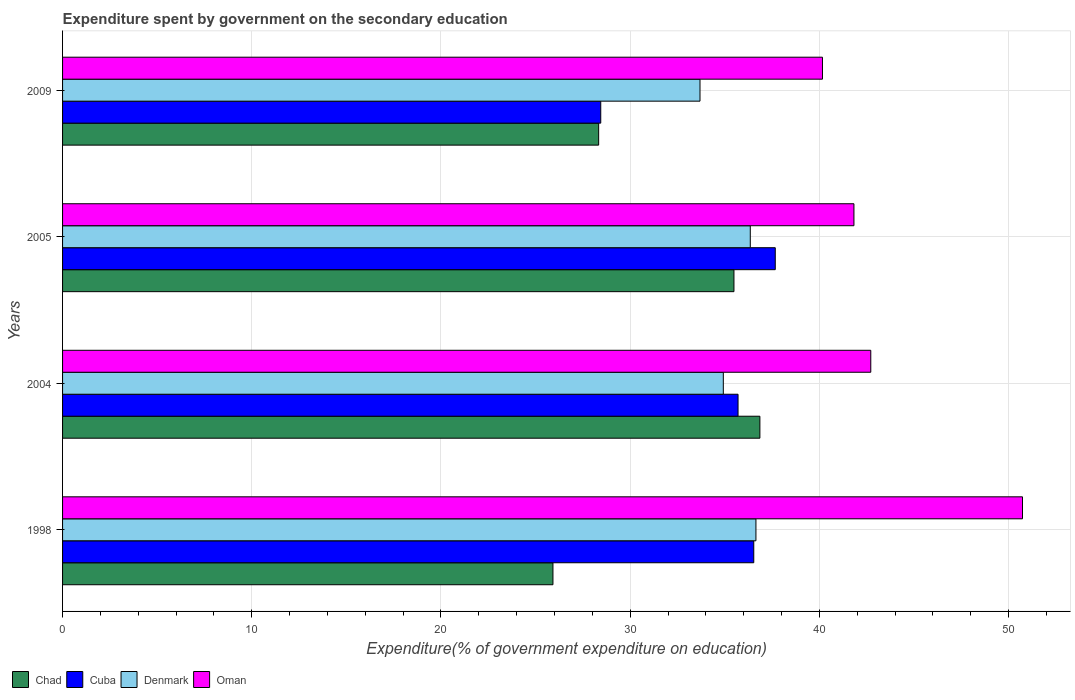How many bars are there on the 4th tick from the top?
Offer a terse response. 4. What is the expenditure spent by government on the secondary education in Cuba in 2009?
Provide a succinct answer. 28.44. Across all years, what is the maximum expenditure spent by government on the secondary education in Oman?
Ensure brevity in your answer.  50.73. Across all years, what is the minimum expenditure spent by government on the secondary education in Cuba?
Give a very brief answer. 28.44. In which year was the expenditure spent by government on the secondary education in Denmark maximum?
Give a very brief answer. 1998. In which year was the expenditure spent by government on the secondary education in Chad minimum?
Give a very brief answer. 1998. What is the total expenditure spent by government on the secondary education in Cuba in the graph?
Provide a short and direct response. 138.35. What is the difference between the expenditure spent by government on the secondary education in Denmark in 2004 and that in 2005?
Provide a succinct answer. -1.43. What is the difference between the expenditure spent by government on the secondary education in Denmark in 2005 and the expenditure spent by government on the secondary education in Chad in 2009?
Provide a succinct answer. 8.01. What is the average expenditure spent by government on the secondary education in Cuba per year?
Provide a short and direct response. 34.59. In the year 2005, what is the difference between the expenditure spent by government on the secondary education in Denmark and expenditure spent by government on the secondary education in Oman?
Make the answer very short. -5.48. In how many years, is the expenditure spent by government on the secondary education in Cuba greater than 38 %?
Offer a very short reply. 0. What is the ratio of the expenditure spent by government on the secondary education in Cuba in 2005 to that in 2009?
Ensure brevity in your answer.  1.32. Is the expenditure spent by government on the secondary education in Denmark in 2005 less than that in 2009?
Your answer should be compact. No. Is the difference between the expenditure spent by government on the secondary education in Denmark in 1998 and 2009 greater than the difference between the expenditure spent by government on the secondary education in Oman in 1998 and 2009?
Offer a very short reply. No. What is the difference between the highest and the second highest expenditure spent by government on the secondary education in Oman?
Your answer should be compact. 8.02. What is the difference between the highest and the lowest expenditure spent by government on the secondary education in Oman?
Your answer should be very brief. 10.57. Is the sum of the expenditure spent by government on the secondary education in Cuba in 2004 and 2009 greater than the maximum expenditure spent by government on the secondary education in Chad across all years?
Your answer should be compact. Yes. Is it the case that in every year, the sum of the expenditure spent by government on the secondary education in Denmark and expenditure spent by government on the secondary education in Oman is greater than the sum of expenditure spent by government on the secondary education in Cuba and expenditure spent by government on the secondary education in Chad?
Make the answer very short. No. What does the 1st bar from the top in 2004 represents?
Give a very brief answer. Oman. What does the 4th bar from the bottom in 2005 represents?
Provide a succinct answer. Oman. Is it the case that in every year, the sum of the expenditure spent by government on the secondary education in Denmark and expenditure spent by government on the secondary education in Oman is greater than the expenditure spent by government on the secondary education in Chad?
Ensure brevity in your answer.  Yes. Are the values on the major ticks of X-axis written in scientific E-notation?
Your answer should be very brief. No. Does the graph contain any zero values?
Provide a succinct answer. No. Where does the legend appear in the graph?
Ensure brevity in your answer.  Bottom left. How are the legend labels stacked?
Provide a short and direct response. Horizontal. What is the title of the graph?
Your answer should be compact. Expenditure spent by government on the secondary education. Does "Yemen, Rep." appear as one of the legend labels in the graph?
Offer a terse response. No. What is the label or title of the X-axis?
Your answer should be compact. Expenditure(% of government expenditure on education). What is the Expenditure(% of government expenditure on education) in Chad in 1998?
Your answer should be compact. 25.92. What is the Expenditure(% of government expenditure on education) of Cuba in 1998?
Your answer should be compact. 36.53. What is the Expenditure(% of government expenditure on education) in Denmark in 1998?
Your answer should be compact. 36.65. What is the Expenditure(% of government expenditure on education) in Oman in 1998?
Your answer should be compact. 50.73. What is the Expenditure(% of government expenditure on education) in Chad in 2004?
Your response must be concise. 36.86. What is the Expenditure(% of government expenditure on education) in Cuba in 2004?
Provide a succinct answer. 35.7. What is the Expenditure(% of government expenditure on education) of Denmark in 2004?
Offer a very short reply. 34.92. What is the Expenditure(% of government expenditure on education) of Oman in 2004?
Give a very brief answer. 42.72. What is the Expenditure(% of government expenditure on education) of Chad in 2005?
Your answer should be very brief. 35.48. What is the Expenditure(% of government expenditure on education) in Cuba in 2005?
Provide a succinct answer. 37.67. What is the Expenditure(% of government expenditure on education) of Denmark in 2005?
Ensure brevity in your answer.  36.35. What is the Expenditure(% of government expenditure on education) of Oman in 2005?
Offer a very short reply. 41.83. What is the Expenditure(% of government expenditure on education) in Chad in 2009?
Provide a short and direct response. 28.33. What is the Expenditure(% of government expenditure on education) in Cuba in 2009?
Provide a short and direct response. 28.44. What is the Expenditure(% of government expenditure on education) in Denmark in 2009?
Your answer should be compact. 33.69. What is the Expenditure(% of government expenditure on education) in Oman in 2009?
Your answer should be very brief. 40.16. Across all years, what is the maximum Expenditure(% of government expenditure on education) in Chad?
Keep it short and to the point. 36.86. Across all years, what is the maximum Expenditure(% of government expenditure on education) in Cuba?
Your response must be concise. 37.67. Across all years, what is the maximum Expenditure(% of government expenditure on education) in Denmark?
Your response must be concise. 36.65. Across all years, what is the maximum Expenditure(% of government expenditure on education) in Oman?
Provide a succinct answer. 50.73. Across all years, what is the minimum Expenditure(% of government expenditure on education) in Chad?
Ensure brevity in your answer.  25.92. Across all years, what is the minimum Expenditure(% of government expenditure on education) in Cuba?
Provide a short and direct response. 28.44. Across all years, what is the minimum Expenditure(% of government expenditure on education) of Denmark?
Ensure brevity in your answer.  33.69. Across all years, what is the minimum Expenditure(% of government expenditure on education) in Oman?
Provide a short and direct response. 40.16. What is the total Expenditure(% of government expenditure on education) in Chad in the graph?
Your answer should be compact. 126.59. What is the total Expenditure(% of government expenditure on education) in Cuba in the graph?
Offer a very short reply. 138.35. What is the total Expenditure(% of government expenditure on education) in Denmark in the graph?
Provide a short and direct response. 141.61. What is the total Expenditure(% of government expenditure on education) in Oman in the graph?
Provide a short and direct response. 175.44. What is the difference between the Expenditure(% of government expenditure on education) of Chad in 1998 and that in 2004?
Offer a terse response. -10.94. What is the difference between the Expenditure(% of government expenditure on education) in Cuba in 1998 and that in 2004?
Give a very brief answer. 0.83. What is the difference between the Expenditure(% of government expenditure on education) in Denmark in 1998 and that in 2004?
Ensure brevity in your answer.  1.72. What is the difference between the Expenditure(% of government expenditure on education) in Oman in 1998 and that in 2004?
Offer a terse response. 8.02. What is the difference between the Expenditure(% of government expenditure on education) of Chad in 1998 and that in 2005?
Give a very brief answer. -9.57. What is the difference between the Expenditure(% of government expenditure on education) of Cuba in 1998 and that in 2005?
Keep it short and to the point. -1.14. What is the difference between the Expenditure(% of government expenditure on education) of Denmark in 1998 and that in 2005?
Provide a succinct answer. 0.3. What is the difference between the Expenditure(% of government expenditure on education) of Oman in 1998 and that in 2005?
Offer a very short reply. 8.91. What is the difference between the Expenditure(% of government expenditure on education) of Chad in 1998 and that in 2009?
Offer a very short reply. -2.42. What is the difference between the Expenditure(% of government expenditure on education) in Cuba in 1998 and that in 2009?
Ensure brevity in your answer.  8.09. What is the difference between the Expenditure(% of government expenditure on education) in Denmark in 1998 and that in 2009?
Offer a very short reply. 2.96. What is the difference between the Expenditure(% of government expenditure on education) in Oman in 1998 and that in 2009?
Provide a short and direct response. 10.57. What is the difference between the Expenditure(% of government expenditure on education) of Chad in 2004 and that in 2005?
Give a very brief answer. 1.37. What is the difference between the Expenditure(% of government expenditure on education) of Cuba in 2004 and that in 2005?
Offer a terse response. -1.97. What is the difference between the Expenditure(% of government expenditure on education) of Denmark in 2004 and that in 2005?
Keep it short and to the point. -1.43. What is the difference between the Expenditure(% of government expenditure on education) of Oman in 2004 and that in 2005?
Provide a short and direct response. 0.89. What is the difference between the Expenditure(% of government expenditure on education) in Chad in 2004 and that in 2009?
Your answer should be compact. 8.52. What is the difference between the Expenditure(% of government expenditure on education) of Cuba in 2004 and that in 2009?
Keep it short and to the point. 7.26. What is the difference between the Expenditure(% of government expenditure on education) of Denmark in 2004 and that in 2009?
Your response must be concise. 1.23. What is the difference between the Expenditure(% of government expenditure on education) in Oman in 2004 and that in 2009?
Give a very brief answer. 2.55. What is the difference between the Expenditure(% of government expenditure on education) in Chad in 2005 and that in 2009?
Offer a terse response. 7.15. What is the difference between the Expenditure(% of government expenditure on education) in Cuba in 2005 and that in 2009?
Offer a terse response. 9.22. What is the difference between the Expenditure(% of government expenditure on education) of Denmark in 2005 and that in 2009?
Your answer should be very brief. 2.66. What is the difference between the Expenditure(% of government expenditure on education) in Oman in 2005 and that in 2009?
Make the answer very short. 1.66. What is the difference between the Expenditure(% of government expenditure on education) in Chad in 1998 and the Expenditure(% of government expenditure on education) in Cuba in 2004?
Provide a short and direct response. -9.78. What is the difference between the Expenditure(% of government expenditure on education) in Chad in 1998 and the Expenditure(% of government expenditure on education) in Denmark in 2004?
Keep it short and to the point. -9. What is the difference between the Expenditure(% of government expenditure on education) of Chad in 1998 and the Expenditure(% of government expenditure on education) of Oman in 2004?
Offer a terse response. -16.8. What is the difference between the Expenditure(% of government expenditure on education) of Cuba in 1998 and the Expenditure(% of government expenditure on education) of Denmark in 2004?
Your answer should be very brief. 1.61. What is the difference between the Expenditure(% of government expenditure on education) of Cuba in 1998 and the Expenditure(% of government expenditure on education) of Oman in 2004?
Offer a terse response. -6.18. What is the difference between the Expenditure(% of government expenditure on education) in Denmark in 1998 and the Expenditure(% of government expenditure on education) in Oman in 2004?
Provide a succinct answer. -6.07. What is the difference between the Expenditure(% of government expenditure on education) in Chad in 1998 and the Expenditure(% of government expenditure on education) in Cuba in 2005?
Provide a succinct answer. -11.75. What is the difference between the Expenditure(% of government expenditure on education) of Chad in 1998 and the Expenditure(% of government expenditure on education) of Denmark in 2005?
Provide a short and direct response. -10.43. What is the difference between the Expenditure(% of government expenditure on education) in Chad in 1998 and the Expenditure(% of government expenditure on education) in Oman in 2005?
Give a very brief answer. -15.91. What is the difference between the Expenditure(% of government expenditure on education) of Cuba in 1998 and the Expenditure(% of government expenditure on education) of Denmark in 2005?
Your response must be concise. 0.18. What is the difference between the Expenditure(% of government expenditure on education) in Cuba in 1998 and the Expenditure(% of government expenditure on education) in Oman in 2005?
Provide a succinct answer. -5.29. What is the difference between the Expenditure(% of government expenditure on education) in Denmark in 1998 and the Expenditure(% of government expenditure on education) in Oman in 2005?
Ensure brevity in your answer.  -5.18. What is the difference between the Expenditure(% of government expenditure on education) in Chad in 1998 and the Expenditure(% of government expenditure on education) in Cuba in 2009?
Keep it short and to the point. -2.53. What is the difference between the Expenditure(% of government expenditure on education) of Chad in 1998 and the Expenditure(% of government expenditure on education) of Denmark in 2009?
Offer a very short reply. -7.77. What is the difference between the Expenditure(% of government expenditure on education) of Chad in 1998 and the Expenditure(% of government expenditure on education) of Oman in 2009?
Offer a very short reply. -14.24. What is the difference between the Expenditure(% of government expenditure on education) in Cuba in 1998 and the Expenditure(% of government expenditure on education) in Denmark in 2009?
Your response must be concise. 2.84. What is the difference between the Expenditure(% of government expenditure on education) in Cuba in 1998 and the Expenditure(% of government expenditure on education) in Oman in 2009?
Provide a short and direct response. -3.63. What is the difference between the Expenditure(% of government expenditure on education) in Denmark in 1998 and the Expenditure(% of government expenditure on education) in Oman in 2009?
Make the answer very short. -3.52. What is the difference between the Expenditure(% of government expenditure on education) of Chad in 2004 and the Expenditure(% of government expenditure on education) of Cuba in 2005?
Give a very brief answer. -0.81. What is the difference between the Expenditure(% of government expenditure on education) of Chad in 2004 and the Expenditure(% of government expenditure on education) of Denmark in 2005?
Make the answer very short. 0.51. What is the difference between the Expenditure(% of government expenditure on education) in Chad in 2004 and the Expenditure(% of government expenditure on education) in Oman in 2005?
Offer a terse response. -4.97. What is the difference between the Expenditure(% of government expenditure on education) in Cuba in 2004 and the Expenditure(% of government expenditure on education) in Denmark in 2005?
Offer a very short reply. -0.65. What is the difference between the Expenditure(% of government expenditure on education) in Cuba in 2004 and the Expenditure(% of government expenditure on education) in Oman in 2005?
Make the answer very short. -6.13. What is the difference between the Expenditure(% of government expenditure on education) of Denmark in 2004 and the Expenditure(% of government expenditure on education) of Oman in 2005?
Provide a short and direct response. -6.9. What is the difference between the Expenditure(% of government expenditure on education) in Chad in 2004 and the Expenditure(% of government expenditure on education) in Cuba in 2009?
Offer a very short reply. 8.41. What is the difference between the Expenditure(% of government expenditure on education) of Chad in 2004 and the Expenditure(% of government expenditure on education) of Denmark in 2009?
Your answer should be compact. 3.17. What is the difference between the Expenditure(% of government expenditure on education) in Chad in 2004 and the Expenditure(% of government expenditure on education) in Oman in 2009?
Your answer should be very brief. -3.31. What is the difference between the Expenditure(% of government expenditure on education) of Cuba in 2004 and the Expenditure(% of government expenditure on education) of Denmark in 2009?
Make the answer very short. 2.01. What is the difference between the Expenditure(% of government expenditure on education) of Cuba in 2004 and the Expenditure(% of government expenditure on education) of Oman in 2009?
Make the answer very short. -4.46. What is the difference between the Expenditure(% of government expenditure on education) in Denmark in 2004 and the Expenditure(% of government expenditure on education) in Oman in 2009?
Give a very brief answer. -5.24. What is the difference between the Expenditure(% of government expenditure on education) in Chad in 2005 and the Expenditure(% of government expenditure on education) in Cuba in 2009?
Make the answer very short. 7.04. What is the difference between the Expenditure(% of government expenditure on education) in Chad in 2005 and the Expenditure(% of government expenditure on education) in Denmark in 2009?
Your answer should be very brief. 1.79. What is the difference between the Expenditure(% of government expenditure on education) of Chad in 2005 and the Expenditure(% of government expenditure on education) of Oman in 2009?
Your answer should be very brief. -4.68. What is the difference between the Expenditure(% of government expenditure on education) of Cuba in 2005 and the Expenditure(% of government expenditure on education) of Denmark in 2009?
Provide a short and direct response. 3.98. What is the difference between the Expenditure(% of government expenditure on education) in Cuba in 2005 and the Expenditure(% of government expenditure on education) in Oman in 2009?
Ensure brevity in your answer.  -2.49. What is the difference between the Expenditure(% of government expenditure on education) of Denmark in 2005 and the Expenditure(% of government expenditure on education) of Oman in 2009?
Your answer should be very brief. -3.82. What is the average Expenditure(% of government expenditure on education) of Chad per year?
Your answer should be very brief. 31.65. What is the average Expenditure(% of government expenditure on education) in Cuba per year?
Keep it short and to the point. 34.59. What is the average Expenditure(% of government expenditure on education) of Denmark per year?
Your response must be concise. 35.4. What is the average Expenditure(% of government expenditure on education) of Oman per year?
Provide a succinct answer. 43.86. In the year 1998, what is the difference between the Expenditure(% of government expenditure on education) of Chad and Expenditure(% of government expenditure on education) of Cuba?
Offer a terse response. -10.61. In the year 1998, what is the difference between the Expenditure(% of government expenditure on education) in Chad and Expenditure(% of government expenditure on education) in Denmark?
Keep it short and to the point. -10.73. In the year 1998, what is the difference between the Expenditure(% of government expenditure on education) in Chad and Expenditure(% of government expenditure on education) in Oman?
Your response must be concise. -24.82. In the year 1998, what is the difference between the Expenditure(% of government expenditure on education) of Cuba and Expenditure(% of government expenditure on education) of Denmark?
Keep it short and to the point. -0.12. In the year 1998, what is the difference between the Expenditure(% of government expenditure on education) of Cuba and Expenditure(% of government expenditure on education) of Oman?
Your response must be concise. -14.2. In the year 1998, what is the difference between the Expenditure(% of government expenditure on education) in Denmark and Expenditure(% of government expenditure on education) in Oman?
Offer a terse response. -14.09. In the year 2004, what is the difference between the Expenditure(% of government expenditure on education) in Chad and Expenditure(% of government expenditure on education) in Cuba?
Offer a terse response. 1.15. In the year 2004, what is the difference between the Expenditure(% of government expenditure on education) in Chad and Expenditure(% of government expenditure on education) in Denmark?
Your answer should be very brief. 1.93. In the year 2004, what is the difference between the Expenditure(% of government expenditure on education) in Chad and Expenditure(% of government expenditure on education) in Oman?
Keep it short and to the point. -5.86. In the year 2004, what is the difference between the Expenditure(% of government expenditure on education) of Cuba and Expenditure(% of government expenditure on education) of Denmark?
Ensure brevity in your answer.  0.78. In the year 2004, what is the difference between the Expenditure(% of government expenditure on education) of Cuba and Expenditure(% of government expenditure on education) of Oman?
Offer a terse response. -7.02. In the year 2004, what is the difference between the Expenditure(% of government expenditure on education) in Denmark and Expenditure(% of government expenditure on education) in Oman?
Ensure brevity in your answer.  -7.79. In the year 2005, what is the difference between the Expenditure(% of government expenditure on education) in Chad and Expenditure(% of government expenditure on education) in Cuba?
Offer a terse response. -2.18. In the year 2005, what is the difference between the Expenditure(% of government expenditure on education) in Chad and Expenditure(% of government expenditure on education) in Denmark?
Ensure brevity in your answer.  -0.86. In the year 2005, what is the difference between the Expenditure(% of government expenditure on education) in Chad and Expenditure(% of government expenditure on education) in Oman?
Give a very brief answer. -6.34. In the year 2005, what is the difference between the Expenditure(% of government expenditure on education) of Cuba and Expenditure(% of government expenditure on education) of Denmark?
Offer a terse response. 1.32. In the year 2005, what is the difference between the Expenditure(% of government expenditure on education) of Cuba and Expenditure(% of government expenditure on education) of Oman?
Your answer should be very brief. -4.16. In the year 2005, what is the difference between the Expenditure(% of government expenditure on education) of Denmark and Expenditure(% of government expenditure on education) of Oman?
Keep it short and to the point. -5.48. In the year 2009, what is the difference between the Expenditure(% of government expenditure on education) of Chad and Expenditure(% of government expenditure on education) of Cuba?
Keep it short and to the point. -0.11. In the year 2009, what is the difference between the Expenditure(% of government expenditure on education) in Chad and Expenditure(% of government expenditure on education) in Denmark?
Offer a terse response. -5.36. In the year 2009, what is the difference between the Expenditure(% of government expenditure on education) in Chad and Expenditure(% of government expenditure on education) in Oman?
Provide a succinct answer. -11.83. In the year 2009, what is the difference between the Expenditure(% of government expenditure on education) in Cuba and Expenditure(% of government expenditure on education) in Denmark?
Make the answer very short. -5.25. In the year 2009, what is the difference between the Expenditure(% of government expenditure on education) of Cuba and Expenditure(% of government expenditure on education) of Oman?
Ensure brevity in your answer.  -11.72. In the year 2009, what is the difference between the Expenditure(% of government expenditure on education) of Denmark and Expenditure(% of government expenditure on education) of Oman?
Keep it short and to the point. -6.47. What is the ratio of the Expenditure(% of government expenditure on education) of Chad in 1998 to that in 2004?
Provide a succinct answer. 0.7. What is the ratio of the Expenditure(% of government expenditure on education) in Cuba in 1998 to that in 2004?
Keep it short and to the point. 1.02. What is the ratio of the Expenditure(% of government expenditure on education) of Denmark in 1998 to that in 2004?
Your answer should be very brief. 1.05. What is the ratio of the Expenditure(% of government expenditure on education) of Oman in 1998 to that in 2004?
Give a very brief answer. 1.19. What is the ratio of the Expenditure(% of government expenditure on education) in Chad in 1998 to that in 2005?
Keep it short and to the point. 0.73. What is the ratio of the Expenditure(% of government expenditure on education) in Cuba in 1998 to that in 2005?
Ensure brevity in your answer.  0.97. What is the ratio of the Expenditure(% of government expenditure on education) of Denmark in 1998 to that in 2005?
Provide a succinct answer. 1.01. What is the ratio of the Expenditure(% of government expenditure on education) of Oman in 1998 to that in 2005?
Keep it short and to the point. 1.21. What is the ratio of the Expenditure(% of government expenditure on education) in Chad in 1998 to that in 2009?
Offer a terse response. 0.91. What is the ratio of the Expenditure(% of government expenditure on education) in Cuba in 1998 to that in 2009?
Your response must be concise. 1.28. What is the ratio of the Expenditure(% of government expenditure on education) of Denmark in 1998 to that in 2009?
Your response must be concise. 1.09. What is the ratio of the Expenditure(% of government expenditure on education) of Oman in 1998 to that in 2009?
Offer a terse response. 1.26. What is the ratio of the Expenditure(% of government expenditure on education) in Chad in 2004 to that in 2005?
Keep it short and to the point. 1.04. What is the ratio of the Expenditure(% of government expenditure on education) of Cuba in 2004 to that in 2005?
Ensure brevity in your answer.  0.95. What is the ratio of the Expenditure(% of government expenditure on education) of Denmark in 2004 to that in 2005?
Give a very brief answer. 0.96. What is the ratio of the Expenditure(% of government expenditure on education) of Oman in 2004 to that in 2005?
Make the answer very short. 1.02. What is the ratio of the Expenditure(% of government expenditure on education) of Chad in 2004 to that in 2009?
Provide a succinct answer. 1.3. What is the ratio of the Expenditure(% of government expenditure on education) in Cuba in 2004 to that in 2009?
Offer a terse response. 1.26. What is the ratio of the Expenditure(% of government expenditure on education) of Denmark in 2004 to that in 2009?
Provide a succinct answer. 1.04. What is the ratio of the Expenditure(% of government expenditure on education) of Oman in 2004 to that in 2009?
Your response must be concise. 1.06. What is the ratio of the Expenditure(% of government expenditure on education) of Chad in 2005 to that in 2009?
Your answer should be very brief. 1.25. What is the ratio of the Expenditure(% of government expenditure on education) in Cuba in 2005 to that in 2009?
Your answer should be very brief. 1.32. What is the ratio of the Expenditure(% of government expenditure on education) of Denmark in 2005 to that in 2009?
Keep it short and to the point. 1.08. What is the ratio of the Expenditure(% of government expenditure on education) of Oman in 2005 to that in 2009?
Make the answer very short. 1.04. What is the difference between the highest and the second highest Expenditure(% of government expenditure on education) in Chad?
Keep it short and to the point. 1.37. What is the difference between the highest and the second highest Expenditure(% of government expenditure on education) of Cuba?
Ensure brevity in your answer.  1.14. What is the difference between the highest and the second highest Expenditure(% of government expenditure on education) of Denmark?
Provide a short and direct response. 0.3. What is the difference between the highest and the second highest Expenditure(% of government expenditure on education) in Oman?
Make the answer very short. 8.02. What is the difference between the highest and the lowest Expenditure(% of government expenditure on education) of Chad?
Provide a short and direct response. 10.94. What is the difference between the highest and the lowest Expenditure(% of government expenditure on education) in Cuba?
Provide a succinct answer. 9.22. What is the difference between the highest and the lowest Expenditure(% of government expenditure on education) of Denmark?
Offer a very short reply. 2.96. What is the difference between the highest and the lowest Expenditure(% of government expenditure on education) in Oman?
Make the answer very short. 10.57. 